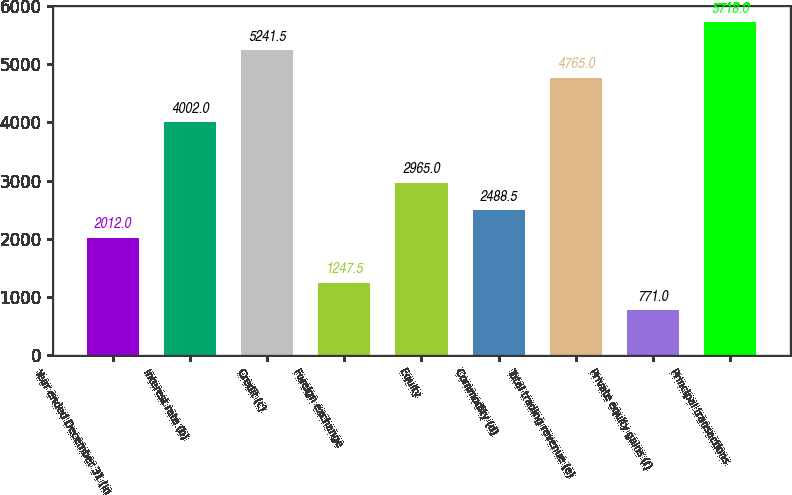<chart> <loc_0><loc_0><loc_500><loc_500><bar_chart><fcel>Year ended December 31 (in<fcel>Interest rate (b)<fcel>Credit (c)<fcel>Foreign exchange<fcel>Equity<fcel>Commodity (d)<fcel>Total trading revenue (e)<fcel>Private equity gains (f)<fcel>Principal transactions<nl><fcel>2012<fcel>4002<fcel>5241.5<fcel>1247.5<fcel>2965<fcel>2488.5<fcel>4765<fcel>771<fcel>5718<nl></chart> 